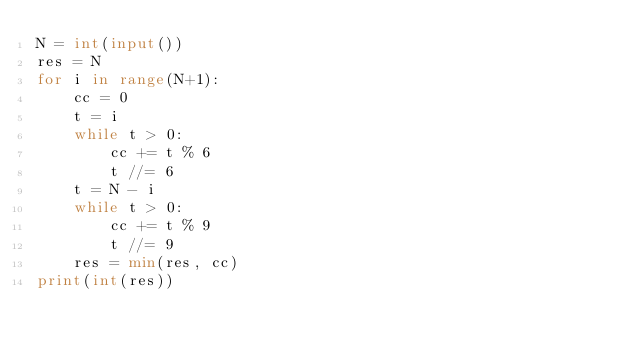<code> <loc_0><loc_0><loc_500><loc_500><_Python_>N = int(input())
res = N
for i in range(N+1):
    cc = 0
    t = i
    while t > 0:
        cc += t % 6
        t //= 6
    t = N - i
    while t > 0:
        cc += t % 9
        t //= 9
    res = min(res, cc)
print(int(res))</code> 